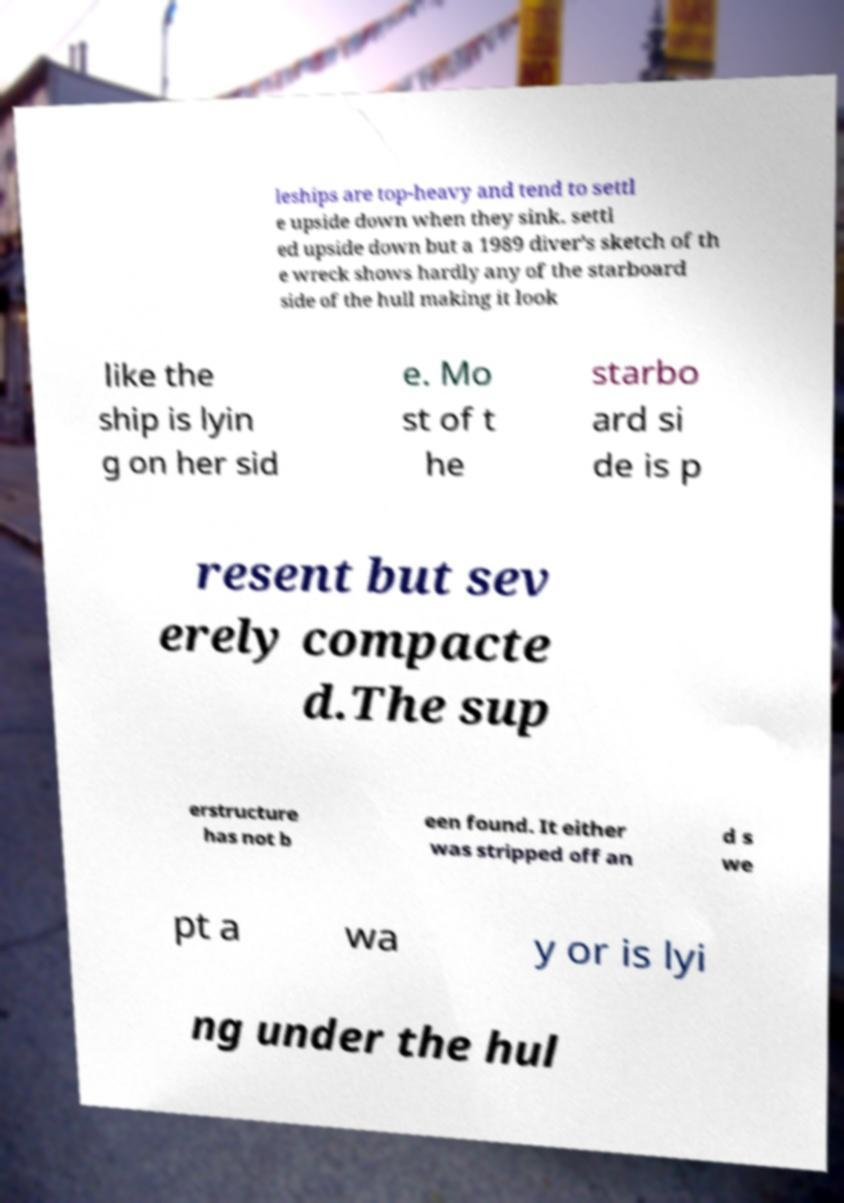Could you assist in decoding the text presented in this image and type it out clearly? leships are top-heavy and tend to settl e upside down when they sink. settl ed upside down but a 1989 diver's sketch of th e wreck shows hardly any of the starboard side of the hull making it look like the ship is lyin g on her sid e. Mo st of t he starbo ard si de is p resent but sev erely compacte d.The sup erstructure has not b een found. It either was stripped off an d s we pt a wa y or is lyi ng under the hul 